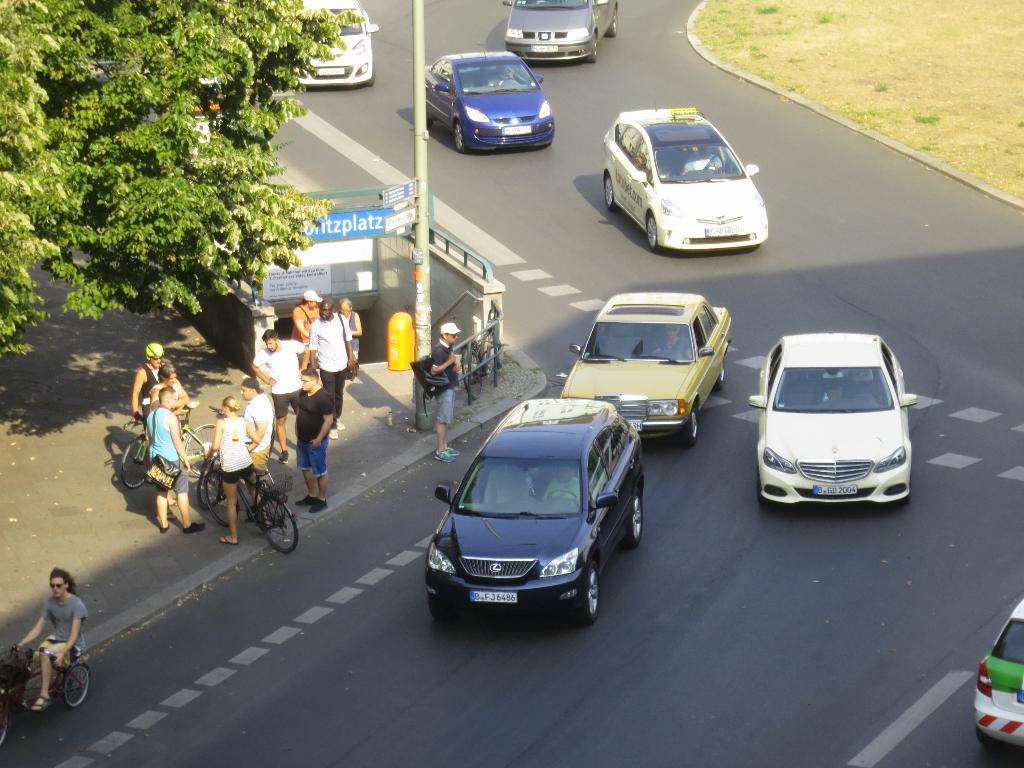In one or two sentences, can you explain what this image depicts? In this image I can see the vehicles on the road. I can see one person with the bicycle. To the side of the road there are the group of people with different color dresses and I can see few people with bicycles. I can also the poles, boards and the trees to the side. 